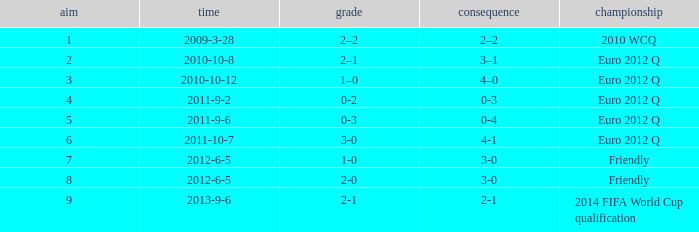What is the result when the score is 0-2? 0-3. 